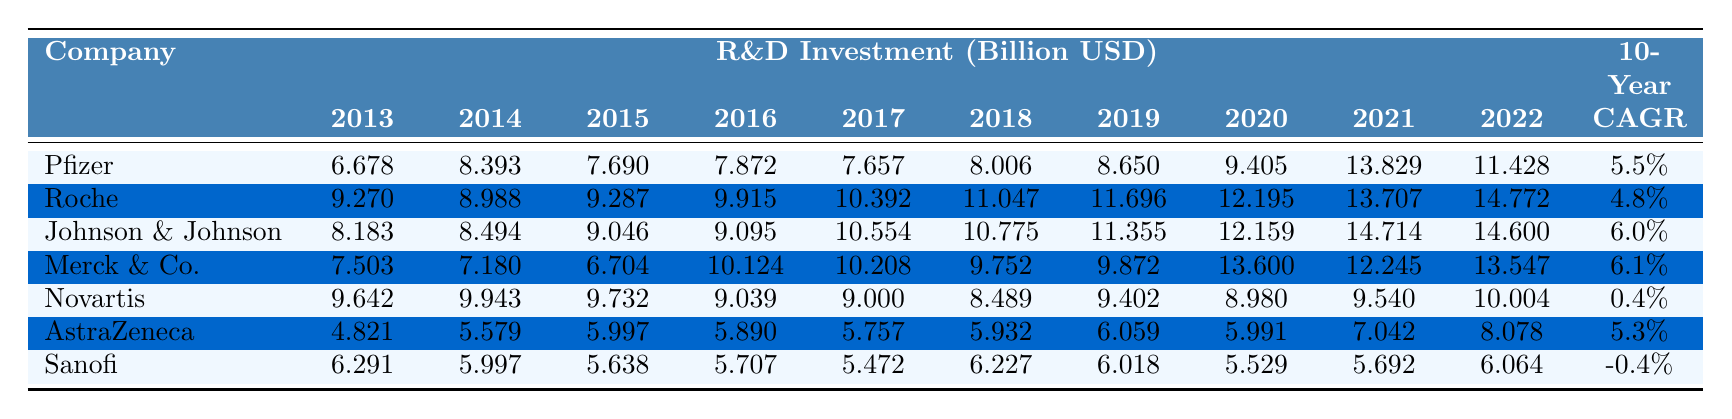What was Pfizer's R&D investment in 2021? From the table, Pfizer's R&D investment for the year 2021 is listed as 13.829 billion USD.
Answer: 13.829 billion USD Which company had the highest R&D investment in 2019? The table shows that Roche had the highest R&D investment in 2019 at 11.696 billion USD compared to the others.
Answer: Roche What is the difference in R&D investment between Johnson & Johnson in 2022 and Novartis in 2022? Johnson & Johnson's R&D investment in 2022 is 14.600 billion USD, while Novartis's investment for the same year is 10.004 billion USD. The difference is 14.600 - 10.004 = 4.596 billion USD.
Answer: 4.596 billion USD Did Sanofi's R&D investment increase over the decade? Looking at the data, Sanofi's R&D investment decreased from 6.291 billion USD in 2013 to 6.064 billion USD in 2022, indicating a decline.
Answer: No Which company had the lowest 10-Year CAGR? The table indicates that Novartis had the lowest 10-Year Compound Annual Growth Rate (CAGR) at 0.4% over the decade.
Answer: Novartis What is the average R&D investment for Merck & Co. from 2013 to 2022? To calculate the average, we sum Merck & Co.’s investments: 7.503 + 7.180 + 6.704 + 10.124 + 10.208 + 9.752 + 9.872 + 13.600 + 12.245 + 13.547 = 88.785. Dividing by 10 gives an average of 8.8785 billion USD.
Answer: 8.8785 billion USD How much did R&D investment for AstraZeneca increase from 2013 to 2022? AstraZeneca's investment rose from 4.821 billion USD in 2013 to 8.078 billion USD in 2022. The increase is 8.078 - 4.821 = 3.257 billion USD.
Answer: 3.257 billion USD Which company had the fastest growth in R&D investment over the decade? Examining the CAGR, Merck & Co. has a CAGR of 6.1%, which is the highest compared to other companies, indicating the fastest growth.
Answer: Merck & Co What was the total R&D investment across all companies in 2020? To find the total, sum all companies' investments in 2020: 9.405 (Pfizer) + 12.195 (Roche) + 12.159 (Johnson & Johnson) + 13.600 (Merck & Co.) + 8.980 (Novartis) + 5.991 (AstraZeneca) + 5.529 (Sanofi) = 67.859 billion USD.
Answer: 67.859 billion USD Was there any year where Sanofi had the highest R&D investment compared to the others? Looking at the table, Sanofi never had the highest investment in any of the years listed, as other companies consistently outperform them.
Answer: No 